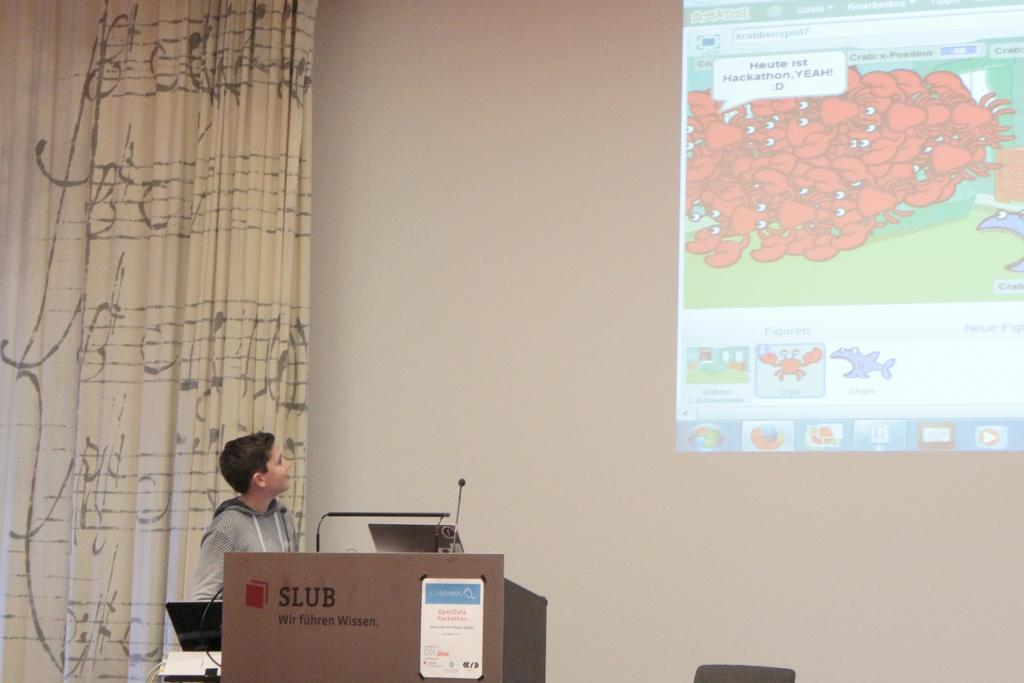What is displayed on the wall in the image? There is a projection on the wall in the image. What can be seen on the left side of the image? There is a curtain on the left side of the image. Who is present in the image? There is a kid in the image. What object is in the image that might be used for presentations or speeches? There is a podium in the image. What type of jam is being used to create the projection on the wall? There is no jam present in the image, and the projection on the wall is not created using jam. Can you describe the monkey's interaction with the curtain in the image? There is no monkey present in the image, so it is not possible to describe any interaction with the curtain. 